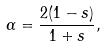<formula> <loc_0><loc_0><loc_500><loc_500>\alpha = \frac { 2 ( 1 - s ) } { 1 + s } , \\</formula> 